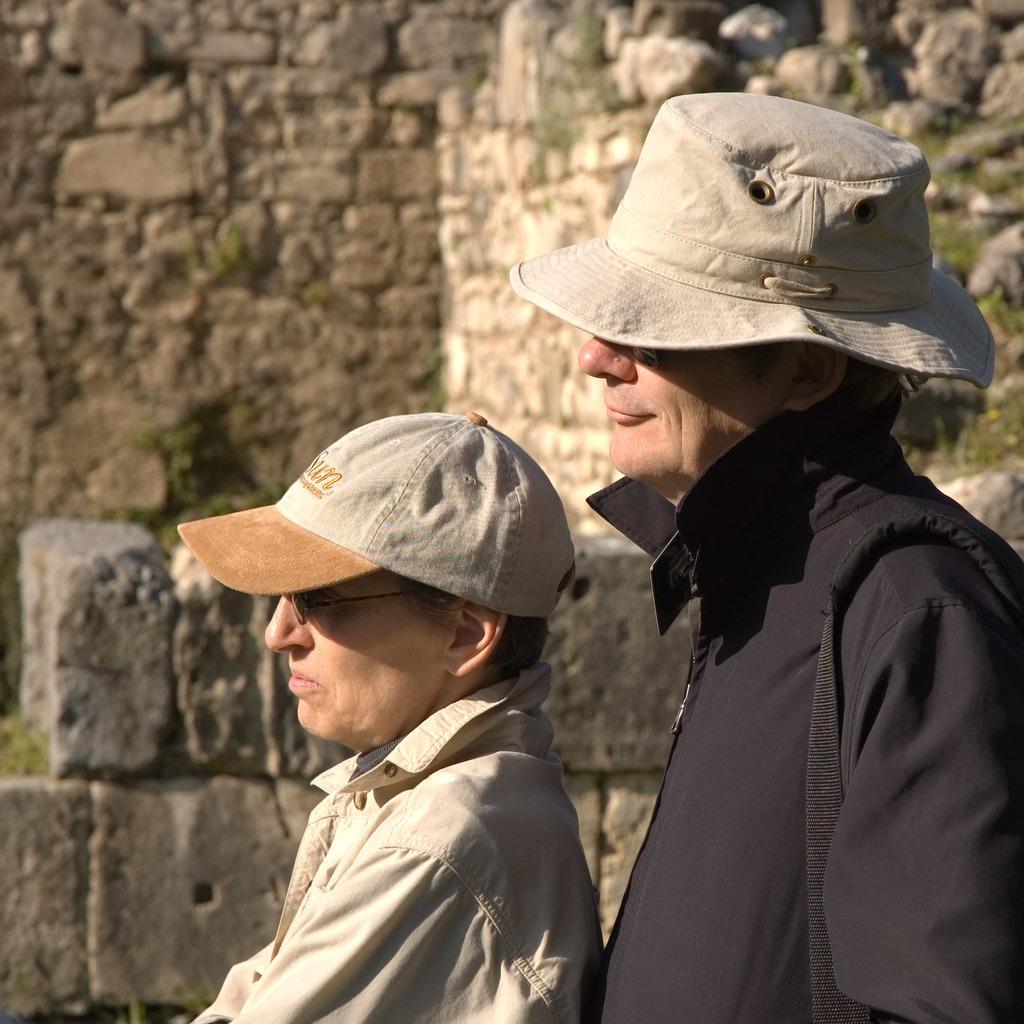Please provide a concise description of this image. On the right side, there is a person in black color shirt, wearing a cap and standing. Beside him, there is another person in gray color shirt, wearing cap and standing. In the background, there is a wall and there are rocks and grass on the ground. 